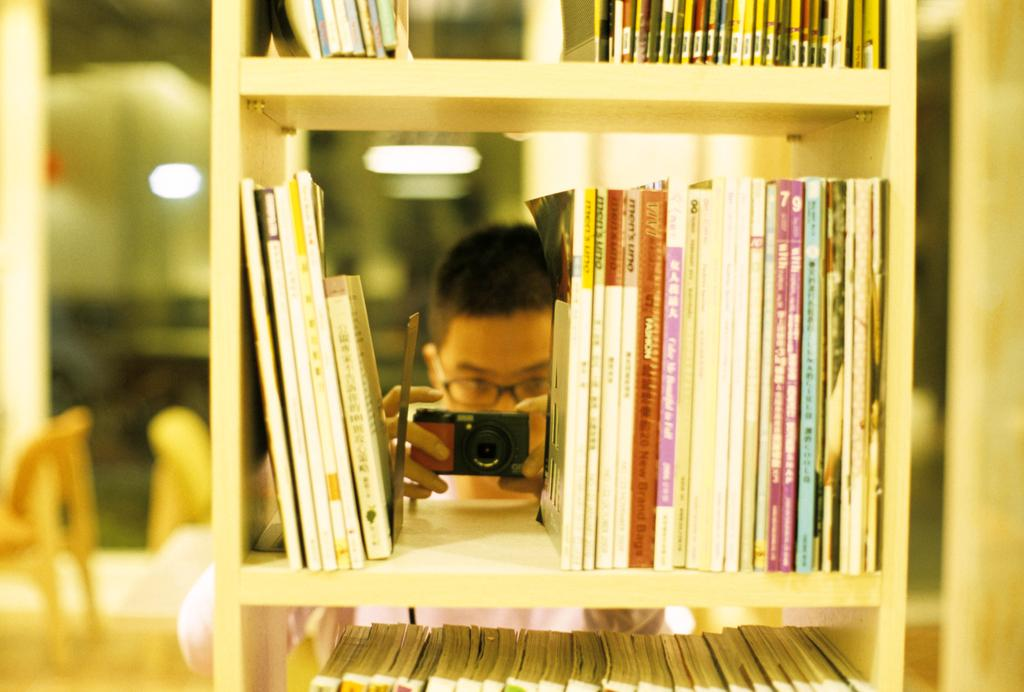What objects can be seen on shelves in the image? There are books on shelves in the image. What is the person in the image doing? The person is holding a camera in the image. What type of robin can be seen sitting on the bookshelf in the image? There is no robin present in the image; it only features books on shelves and a person holding a camera. What drug is the person holding in the image? There is no drug present in the image; the person is holding a camera. 